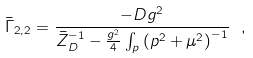<formula> <loc_0><loc_0><loc_500><loc_500>\bar { \Gamma } _ { 2 , 2 } = \frac { - D g ^ { 2 } } { \bar { Z } _ { D } ^ { - 1 } - \frac { g ^ { 2 } } { 4 } \int _ { p } \left ( p ^ { 2 } + \mu ^ { 2 } \right ) ^ { - 1 } } \ ,</formula> 